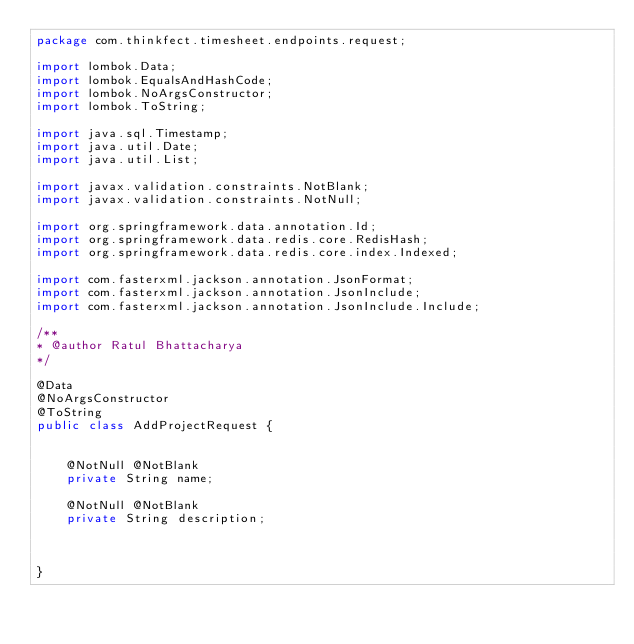Convert code to text. <code><loc_0><loc_0><loc_500><loc_500><_Java_>package com.thinkfect.timesheet.endpoints.request;

import lombok.Data;
import lombok.EqualsAndHashCode;
import lombok.NoArgsConstructor;
import lombok.ToString;

import java.sql.Timestamp;
import java.util.Date;
import java.util.List;

import javax.validation.constraints.NotBlank;
import javax.validation.constraints.NotNull;

import org.springframework.data.annotation.Id;
import org.springframework.data.redis.core.RedisHash;
import org.springframework.data.redis.core.index.Indexed;

import com.fasterxml.jackson.annotation.JsonFormat;
import com.fasterxml.jackson.annotation.JsonInclude;
import com.fasterxml.jackson.annotation.JsonInclude.Include;

/**
* @author Ratul Bhattacharya
*/

@Data
@NoArgsConstructor
@ToString
public class AddProjectRequest {


	@NotNull @NotBlank
	private String name;
	
	@NotNull @NotBlank
	private String description;
	
	
	
}
</code> 